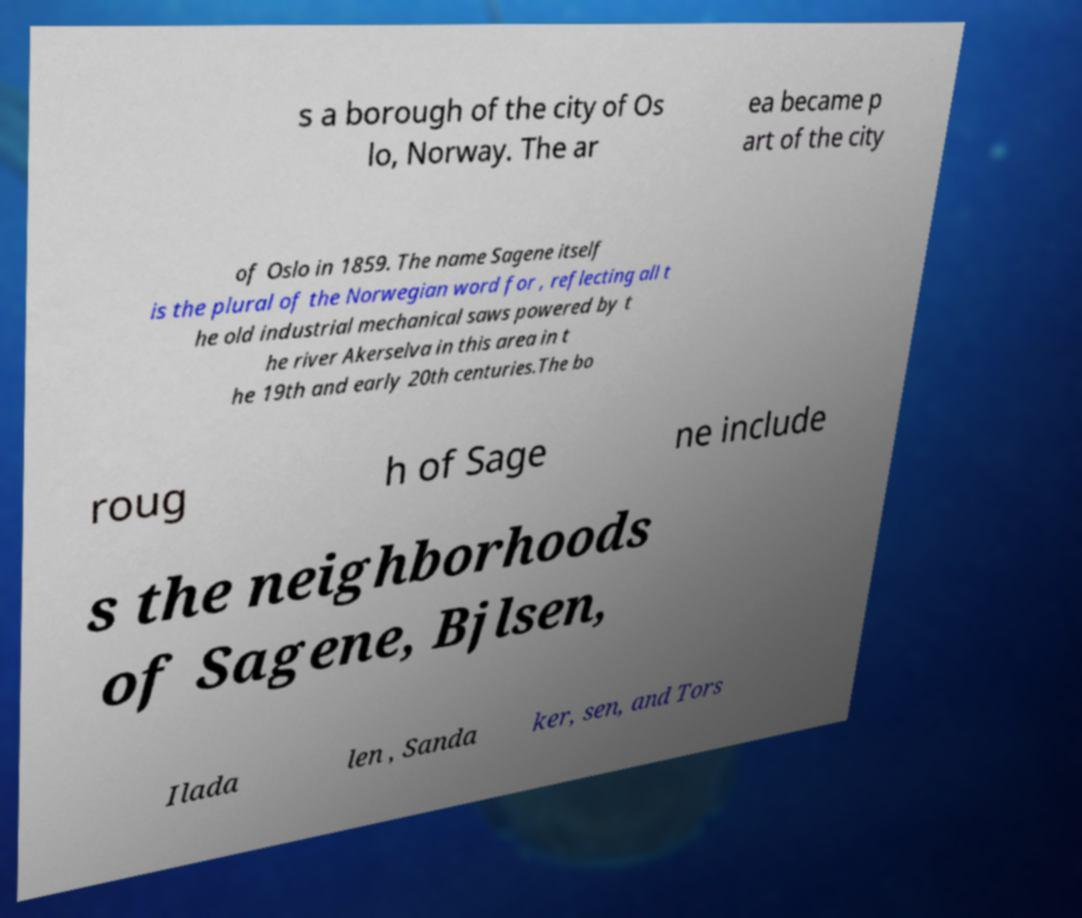What messages or text are displayed in this image? I need them in a readable, typed format. s a borough of the city of Os lo, Norway. The ar ea became p art of the city of Oslo in 1859. The name Sagene itself is the plural of the Norwegian word for , reflecting all t he old industrial mechanical saws powered by t he river Akerselva in this area in t he 19th and early 20th centuries.The bo roug h of Sage ne include s the neighborhoods of Sagene, Bjlsen, Ilada len , Sanda ker, sen, and Tors 